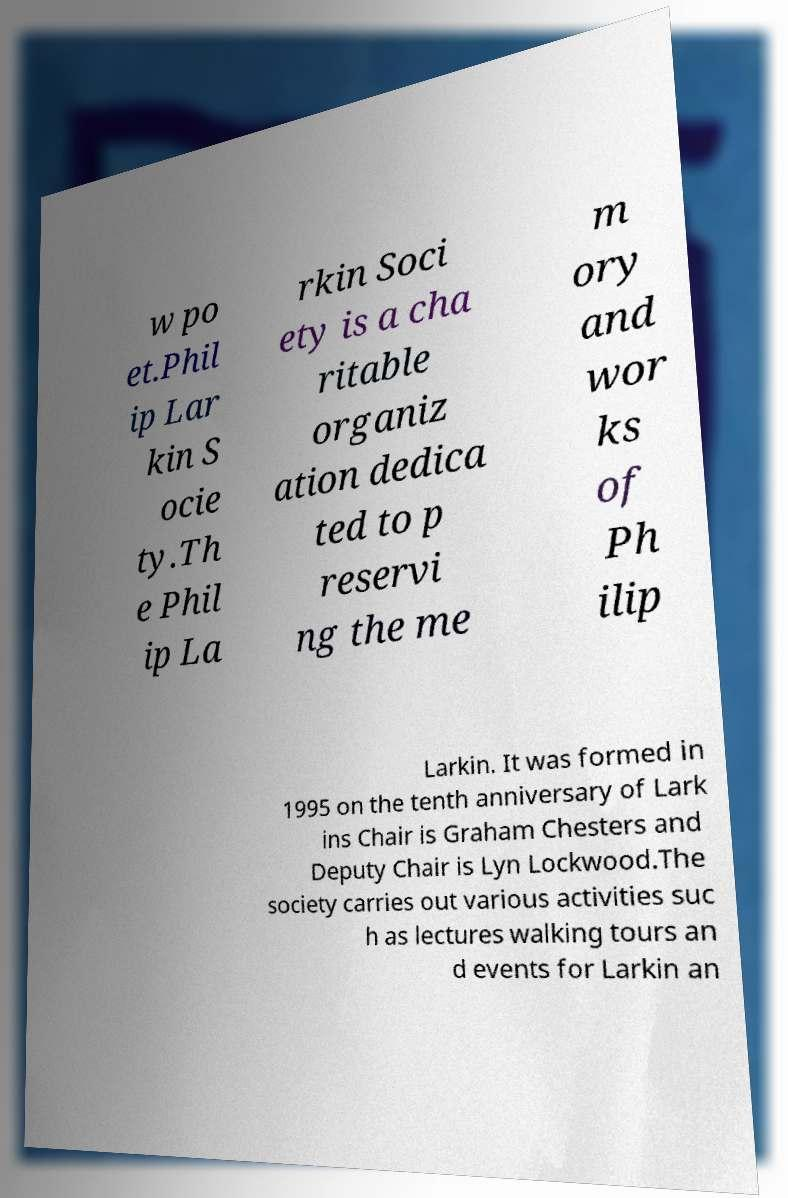There's text embedded in this image that I need extracted. Can you transcribe it verbatim? w po et.Phil ip Lar kin S ocie ty.Th e Phil ip La rkin Soci ety is a cha ritable organiz ation dedica ted to p reservi ng the me m ory and wor ks of Ph ilip Larkin. It was formed in 1995 on the tenth anniversary of Lark ins Chair is Graham Chesters and Deputy Chair is Lyn Lockwood.The society carries out various activities suc h as lectures walking tours an d events for Larkin an 